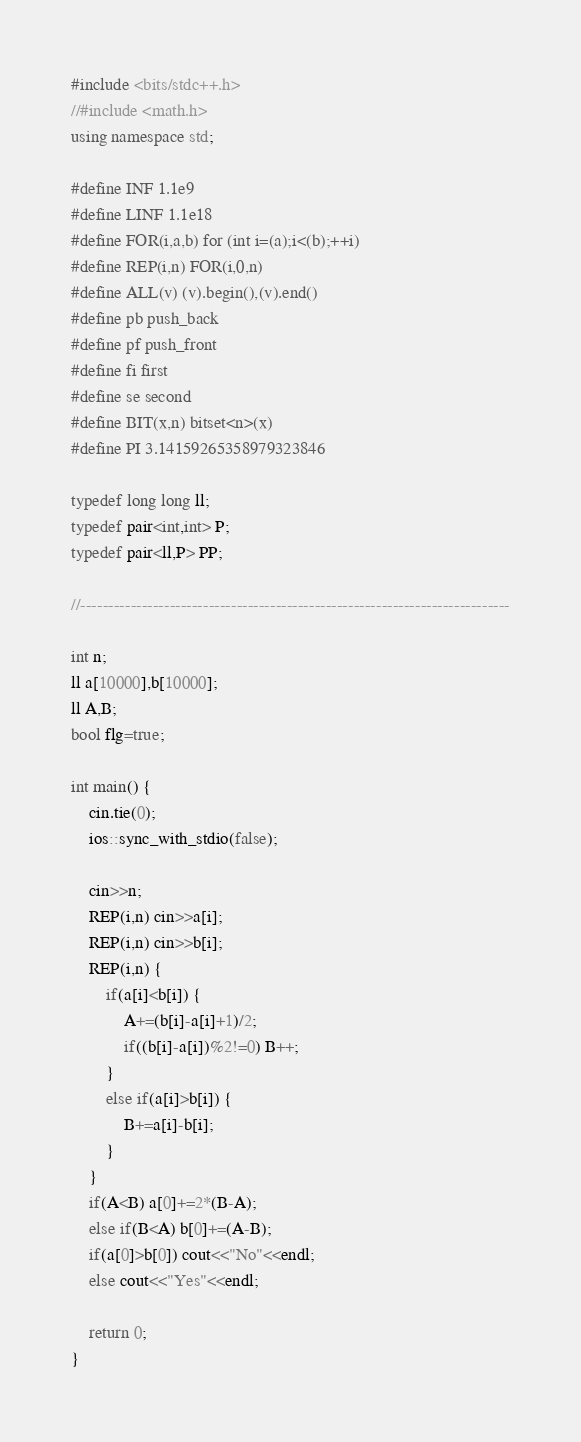<code> <loc_0><loc_0><loc_500><loc_500><_C++_>#include <bits/stdc++.h>
//#include <math.h>
using namespace std;

#define INF 1.1e9
#define LINF 1.1e18
#define FOR(i,a,b) for (int i=(a);i<(b);++i)
#define REP(i,n) FOR(i,0,n)
#define ALL(v) (v).begin(),(v).end()
#define pb push_back
#define pf push_front
#define fi first
#define se second
#define BIT(x,n) bitset<n>(x)
#define PI 3.14159265358979323846

typedef long long ll;
typedef pair<int,int> P;
typedef pair<ll,P> PP;

//-----------------------------------------------------------------------------

int n;
ll a[10000],b[10000];
ll A,B;
bool flg=true;

int main() {
	cin.tie(0);
	ios::sync_with_stdio(false);

	cin>>n;
	REP(i,n) cin>>a[i];
	REP(i,n) cin>>b[i];
	REP(i,n) {
		if(a[i]<b[i]) {
			A+=(b[i]-a[i]+1)/2;
			if((b[i]-a[i])%2!=0) B++;
		}
		else if(a[i]>b[i]) {
			B+=a[i]-b[i];
		}
	}
	if(A<B) a[0]+=2*(B-A);
	else if(B<A) b[0]+=(A-B);
	if(a[0]>b[0]) cout<<"No"<<endl;
	else cout<<"Yes"<<endl;

	return 0;
}
</code> 